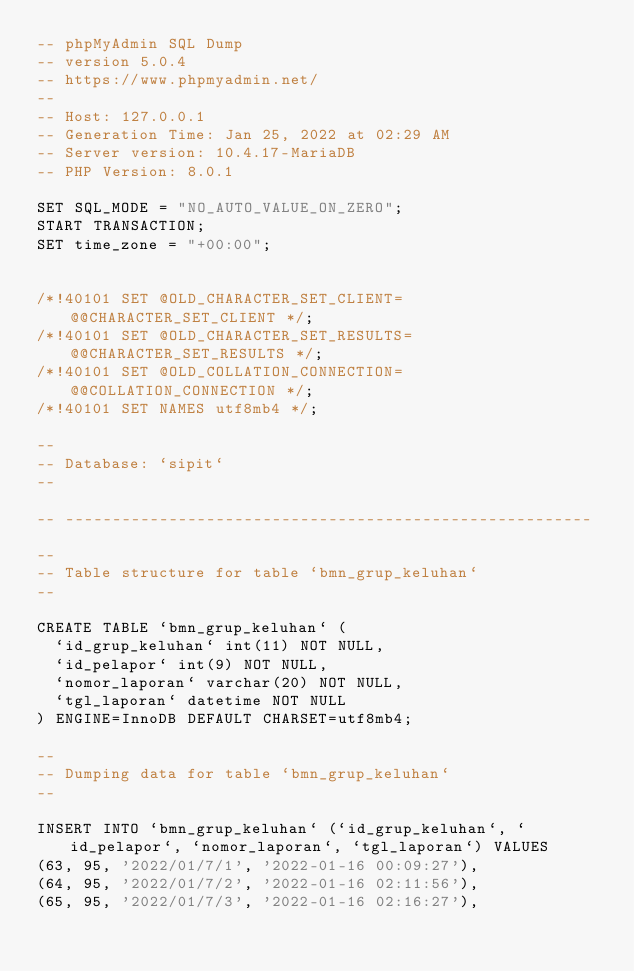<code> <loc_0><loc_0><loc_500><loc_500><_SQL_>-- phpMyAdmin SQL Dump
-- version 5.0.4
-- https://www.phpmyadmin.net/
--
-- Host: 127.0.0.1
-- Generation Time: Jan 25, 2022 at 02:29 AM
-- Server version: 10.4.17-MariaDB
-- PHP Version: 8.0.1

SET SQL_MODE = "NO_AUTO_VALUE_ON_ZERO";
START TRANSACTION;
SET time_zone = "+00:00";


/*!40101 SET @OLD_CHARACTER_SET_CLIENT=@@CHARACTER_SET_CLIENT */;
/*!40101 SET @OLD_CHARACTER_SET_RESULTS=@@CHARACTER_SET_RESULTS */;
/*!40101 SET @OLD_COLLATION_CONNECTION=@@COLLATION_CONNECTION */;
/*!40101 SET NAMES utf8mb4 */;

--
-- Database: `sipit`
--

-- --------------------------------------------------------

--
-- Table structure for table `bmn_grup_keluhan`
--

CREATE TABLE `bmn_grup_keluhan` (
  `id_grup_keluhan` int(11) NOT NULL,
  `id_pelapor` int(9) NOT NULL,
  `nomor_laporan` varchar(20) NOT NULL,
  `tgl_laporan` datetime NOT NULL
) ENGINE=InnoDB DEFAULT CHARSET=utf8mb4;

--
-- Dumping data for table `bmn_grup_keluhan`
--

INSERT INTO `bmn_grup_keluhan` (`id_grup_keluhan`, `id_pelapor`, `nomor_laporan`, `tgl_laporan`) VALUES
(63, 95, '2022/01/7/1', '2022-01-16 00:09:27'),
(64, 95, '2022/01/7/2', '2022-01-16 02:11:56'),
(65, 95, '2022/01/7/3', '2022-01-16 02:16:27'),</code> 